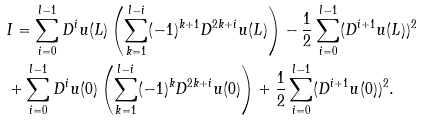Convert formula to latex. <formula><loc_0><loc_0><loc_500><loc_500>& I = \sum _ { i = 0 } ^ { l - 1 } D ^ { i } u ( L ) \left ( \sum _ { k = 1 } ^ { l - i } ( - 1 ) ^ { k + 1 } D ^ { 2 k + i } u ( L ) \right ) - \frac { 1 } { 2 } \sum _ { i = 0 } ^ { l - 1 } ( D ^ { i + 1 } u ( L ) ) ^ { 2 } \\ & + \sum _ { i = 0 } ^ { l - 1 } D ^ { i } u ( 0 ) \left ( \sum _ { k = 1 } ^ { l - i } ( - 1 ) ^ { k } D ^ { 2 k + i } u ( 0 ) \right ) + \frac { 1 } { 2 } \sum _ { i = 0 } ^ { l - 1 } ( D ^ { i + 1 } u ( 0 ) ) ^ { 2 } .</formula> 